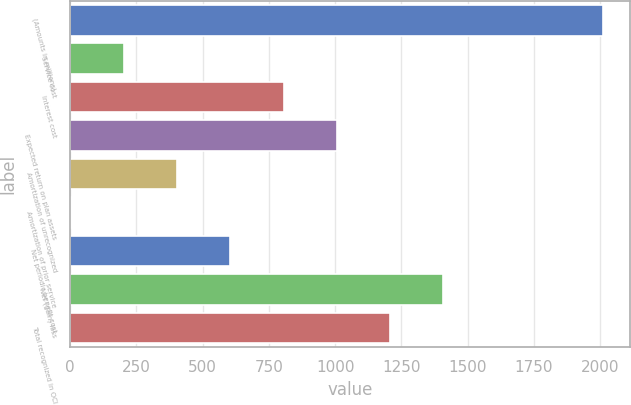<chart> <loc_0><loc_0><loc_500><loc_500><bar_chart><fcel>(Amounts in millions)<fcel>Service cost<fcel>Interest cost<fcel>Expected return on plan assets<fcel>Amortization of unrecognized<fcel>Amortization of prior service<fcel>Net periodic benefit cost<fcel>Net (gain) loss<fcel>Total recognized in OCI<nl><fcel>2011<fcel>202.09<fcel>805.06<fcel>1006.05<fcel>403.08<fcel>1.1<fcel>604.07<fcel>1408.03<fcel>1207.04<nl></chart> 